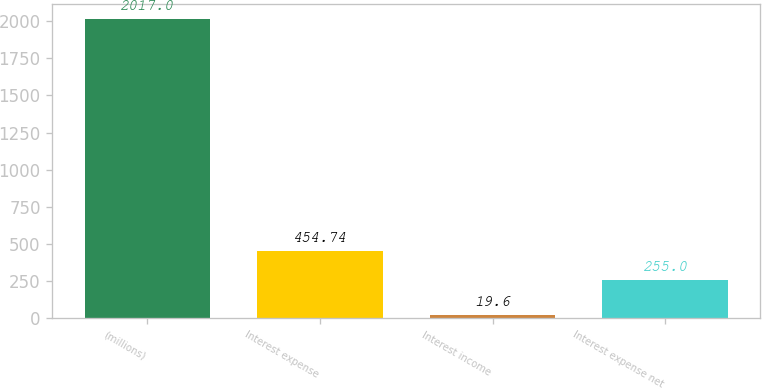<chart> <loc_0><loc_0><loc_500><loc_500><bar_chart><fcel>(millions)<fcel>Interest expense<fcel>Interest income<fcel>Interest expense net<nl><fcel>2017<fcel>454.74<fcel>19.6<fcel>255<nl></chart> 